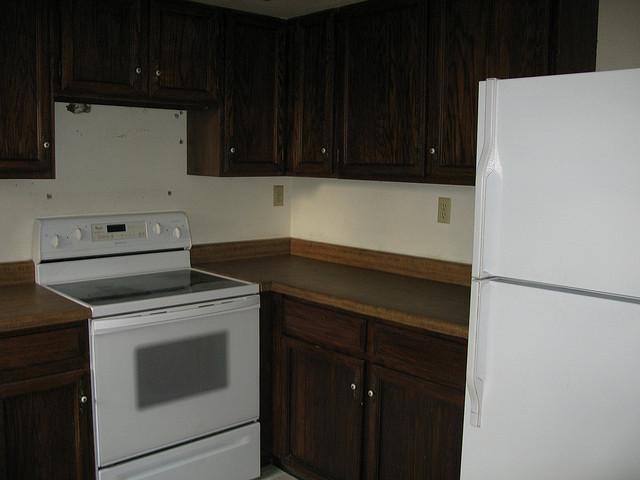How many candles are in this scene?
Give a very brief answer. 0. How many appliances in this photo?
Give a very brief answer. 2. How many rings are on the stove?
Give a very brief answer. 4. 